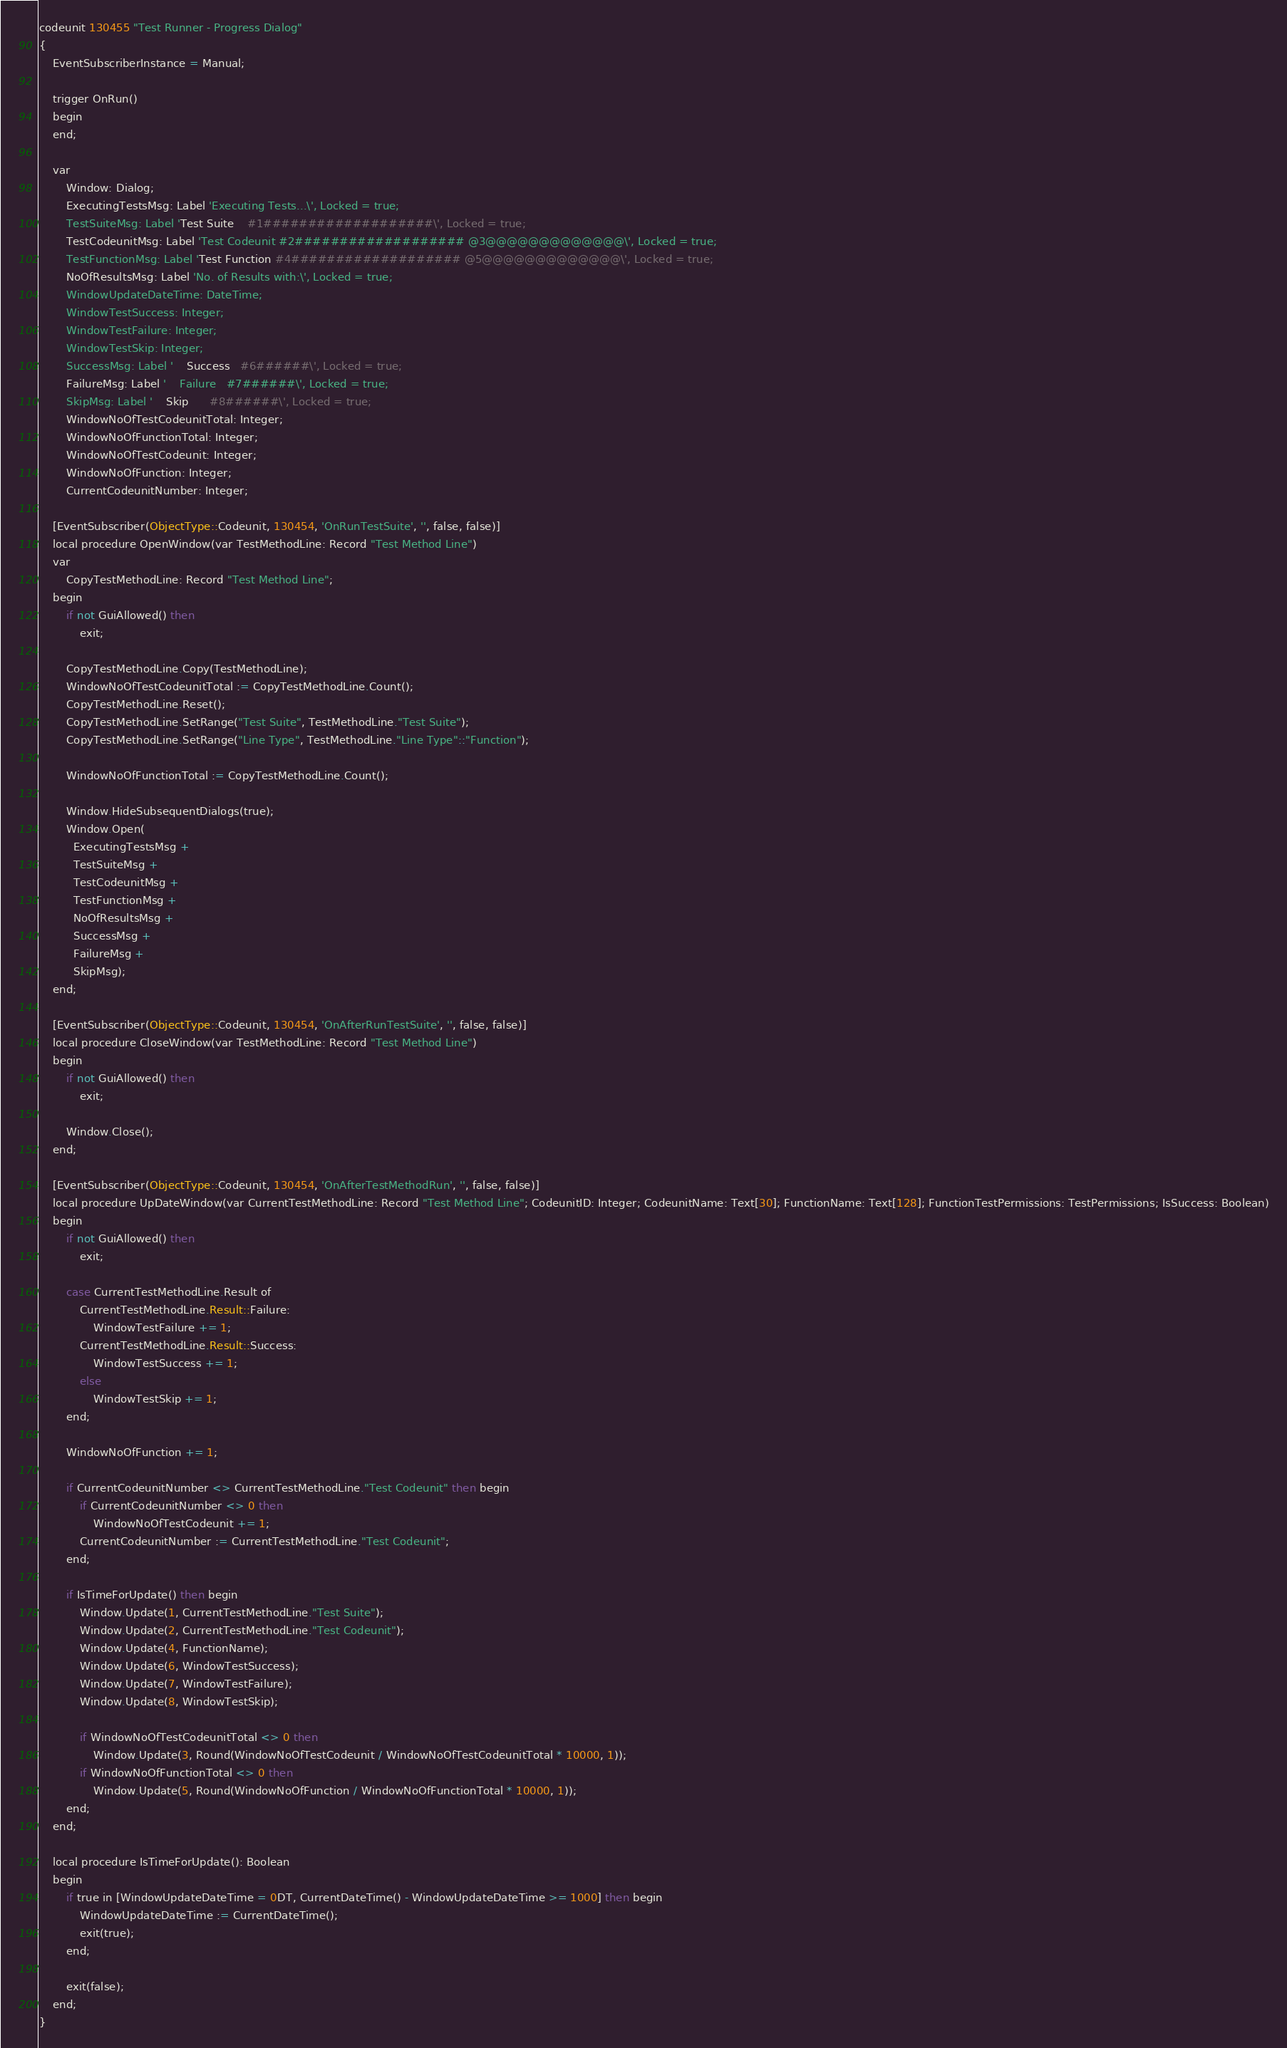Convert code to text. <code><loc_0><loc_0><loc_500><loc_500><_Perl_>codeunit 130455 "Test Runner - Progress Dialog"
{
    EventSubscriberInstance = Manual;

    trigger OnRun()
    begin
    end;

    var
        Window: Dialog;
        ExecutingTestsMsg: Label 'Executing Tests...\', Locked = true;
        TestSuiteMsg: Label 'Test Suite    #1###################\', Locked = true;
        TestCodeunitMsg: Label 'Test Codeunit #2################### @3@@@@@@@@@@@@@\', Locked = true;
        TestFunctionMsg: Label 'Test Function #4################### @5@@@@@@@@@@@@@\', Locked = true;
        NoOfResultsMsg: Label 'No. of Results with:\', Locked = true;
        WindowUpdateDateTime: DateTime;
        WindowTestSuccess: Integer;
        WindowTestFailure: Integer;
        WindowTestSkip: Integer;
        SuccessMsg: Label '    Success   #6######\', Locked = true;
        FailureMsg: Label '    Failure   #7######\', Locked = true;
        SkipMsg: Label '    Skip      #8######\', Locked = true;
        WindowNoOfTestCodeunitTotal: Integer;
        WindowNoOfFunctionTotal: Integer;
        WindowNoOfTestCodeunit: Integer;
        WindowNoOfFunction: Integer;
        CurrentCodeunitNumber: Integer;

    [EventSubscriber(ObjectType::Codeunit, 130454, 'OnRunTestSuite', '', false, false)]
    local procedure OpenWindow(var TestMethodLine: Record "Test Method Line")
    var
        CopyTestMethodLine: Record "Test Method Line";
    begin
        if not GuiAllowed() then
            exit;

        CopyTestMethodLine.Copy(TestMethodLine);
        WindowNoOfTestCodeunitTotal := CopyTestMethodLine.Count();
        CopyTestMethodLine.Reset();
        CopyTestMethodLine.SetRange("Test Suite", TestMethodLine."Test Suite");
        CopyTestMethodLine.SetRange("Line Type", TestMethodLine."Line Type"::"Function");

        WindowNoOfFunctionTotal := CopyTestMethodLine.Count();

        Window.HideSubsequentDialogs(true);
        Window.Open(
          ExecutingTestsMsg +
          TestSuiteMsg +
          TestCodeunitMsg +
          TestFunctionMsg +
          NoOfResultsMsg +
          SuccessMsg +
          FailureMsg +
          SkipMsg);
    end;

    [EventSubscriber(ObjectType::Codeunit, 130454, 'OnAfterRunTestSuite', '', false, false)]
    local procedure CloseWindow(var TestMethodLine: Record "Test Method Line")
    begin
        if not GuiAllowed() then
            exit;

        Window.Close();
    end;

    [EventSubscriber(ObjectType::Codeunit, 130454, 'OnAfterTestMethodRun', '', false, false)]
    local procedure UpDateWindow(var CurrentTestMethodLine: Record "Test Method Line"; CodeunitID: Integer; CodeunitName: Text[30]; FunctionName: Text[128]; FunctionTestPermissions: TestPermissions; IsSuccess: Boolean)
    begin
        if not GuiAllowed() then
            exit;

        case CurrentTestMethodLine.Result of
            CurrentTestMethodLine.Result::Failure:
                WindowTestFailure += 1;
            CurrentTestMethodLine.Result::Success:
                WindowTestSuccess += 1;
            else
                WindowTestSkip += 1;
        end;

        WindowNoOfFunction += 1;

        if CurrentCodeunitNumber <> CurrentTestMethodLine."Test Codeunit" then begin
            if CurrentCodeunitNumber <> 0 then
                WindowNoOfTestCodeunit += 1;
            CurrentCodeunitNumber := CurrentTestMethodLine."Test Codeunit";
        end;

        if IsTimeForUpdate() then begin
            Window.Update(1, CurrentTestMethodLine."Test Suite");
            Window.Update(2, CurrentTestMethodLine."Test Codeunit");
            Window.Update(4, FunctionName);
            Window.Update(6, WindowTestSuccess);
            Window.Update(7, WindowTestFailure);
            Window.Update(8, WindowTestSkip);

            if WindowNoOfTestCodeunitTotal <> 0 then
                Window.Update(3, Round(WindowNoOfTestCodeunit / WindowNoOfTestCodeunitTotal * 10000, 1));
            if WindowNoOfFunctionTotal <> 0 then
                Window.Update(5, Round(WindowNoOfFunction / WindowNoOfFunctionTotal * 10000, 1));
        end;
    end;

    local procedure IsTimeForUpdate(): Boolean
    begin
        if true in [WindowUpdateDateTime = 0DT, CurrentDateTime() - WindowUpdateDateTime >= 1000] then begin
            WindowUpdateDateTime := CurrentDateTime();
            exit(true);
        end;

        exit(false);
    end;
}

</code> 